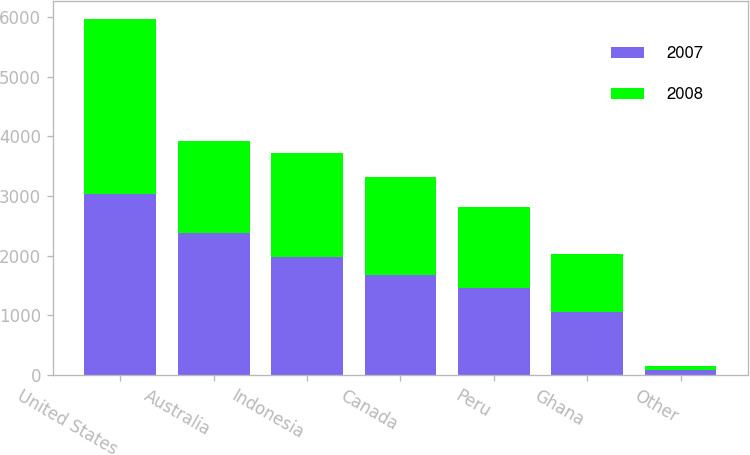Convert chart to OTSL. <chart><loc_0><loc_0><loc_500><loc_500><stacked_bar_chart><ecel><fcel>United States<fcel>Australia<fcel>Indonesia<fcel>Canada<fcel>Peru<fcel>Ghana<fcel>Other<nl><fcel>2007<fcel>3034<fcel>2371<fcel>1980<fcel>1671<fcel>1461<fcel>1051<fcel>77<nl><fcel>2008<fcel>2932<fcel>1555<fcel>1744<fcel>1639<fcel>1357<fcel>974<fcel>74<nl></chart> 